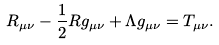Convert formula to latex. <formula><loc_0><loc_0><loc_500><loc_500>R _ { \mu \nu } - \frac { 1 } { 2 } R g _ { \mu \nu } + \Lambda g _ { \mu \nu } = T _ { \mu \nu } .</formula> 